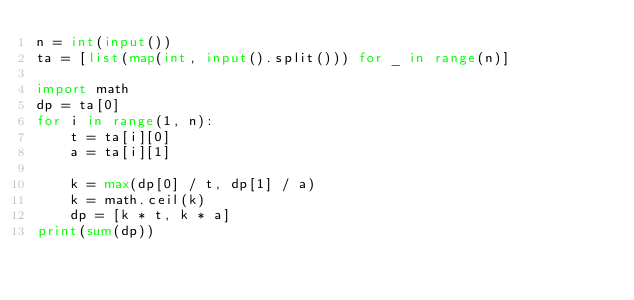Convert code to text. <code><loc_0><loc_0><loc_500><loc_500><_Python_>n = int(input())
ta = [list(map(int, input().split())) for _ in range(n)]

import math
dp = ta[0]
for i in range(1, n):
    t = ta[i][0]
    a = ta[i][1]

    k = max(dp[0] / t, dp[1] / a)
    k = math.ceil(k)
    dp = [k * t, k * a]
print(sum(dp))
</code> 